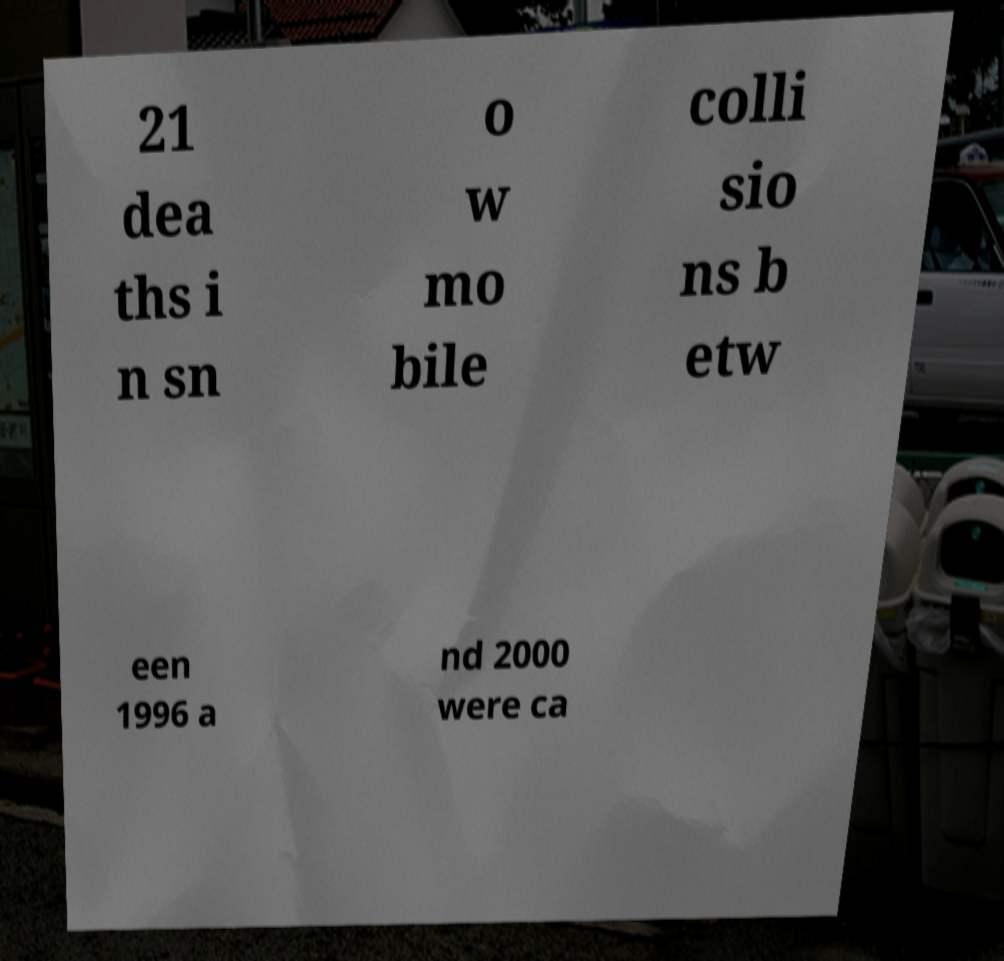I need the written content from this picture converted into text. Can you do that? 21 dea ths i n sn o w mo bile colli sio ns b etw een 1996 a nd 2000 were ca 